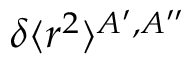Convert formula to latex. <formula><loc_0><loc_0><loc_500><loc_500>\delta \langle r ^ { 2 } \rangle ^ { A ^ { \prime } , A ^ { \prime \prime } }</formula> 